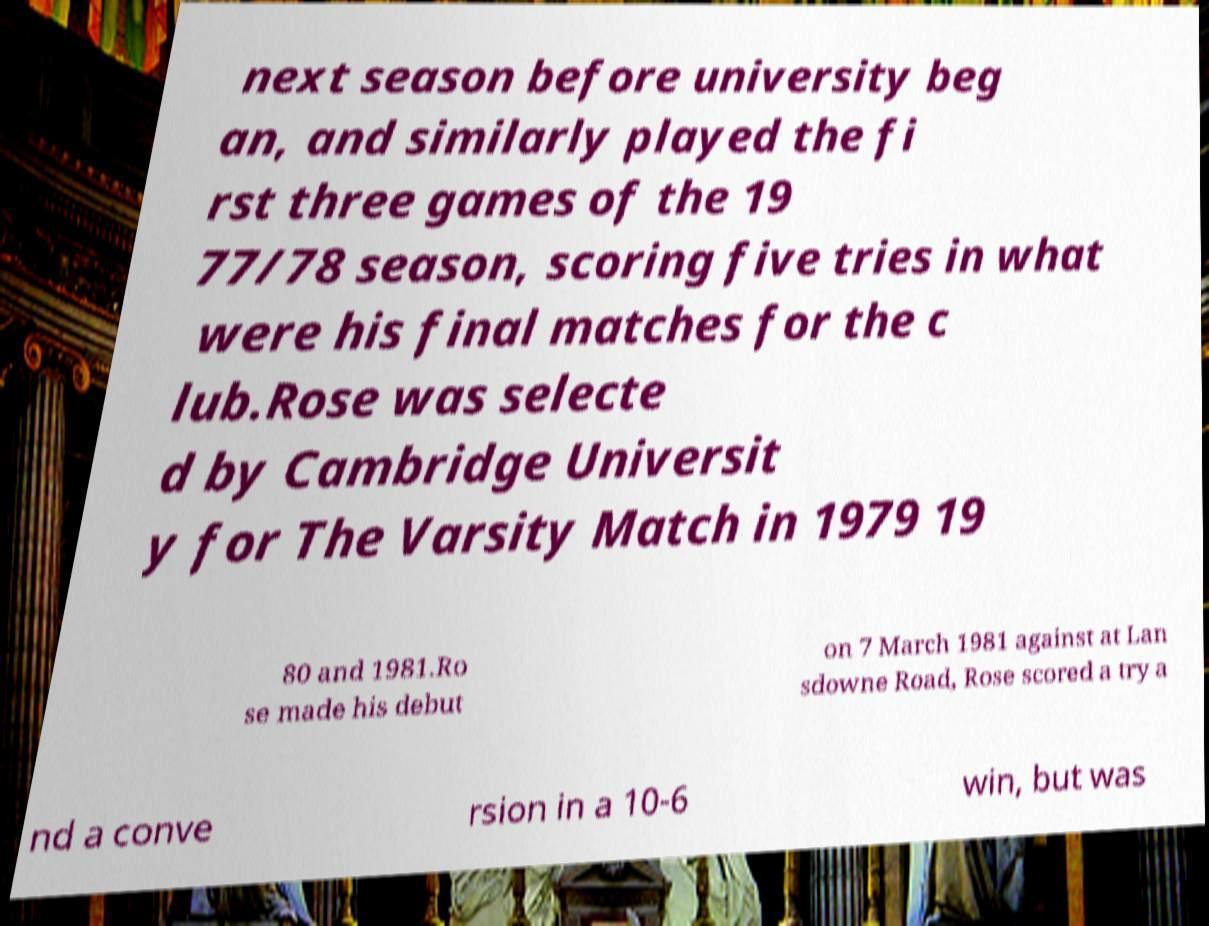Can you accurately transcribe the text from the provided image for me? next season before university beg an, and similarly played the fi rst three games of the 19 77/78 season, scoring five tries in what were his final matches for the c lub.Rose was selecte d by Cambridge Universit y for The Varsity Match in 1979 19 80 and 1981.Ro se made his debut on 7 March 1981 against at Lan sdowne Road, Rose scored a try a nd a conve rsion in a 10-6 win, but was 